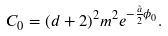Convert formula to latex. <formula><loc_0><loc_0><loc_500><loc_500>C _ { 0 } = ( d + 2 ) ^ { 2 } m ^ { 2 } e ^ { - \frac { \tilde { a } } { 2 } \phi _ { 0 } } .</formula> 